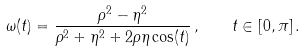Convert formula to latex. <formula><loc_0><loc_0><loc_500><loc_500>\omega ( t ) = \frac { \rho ^ { 2 } - \eta ^ { 2 } } { \rho ^ { 2 } + \eta ^ { 2 } + 2 \rho \eta \cos ( t ) } \, , \quad t \in [ 0 , \pi ] \, .</formula> 